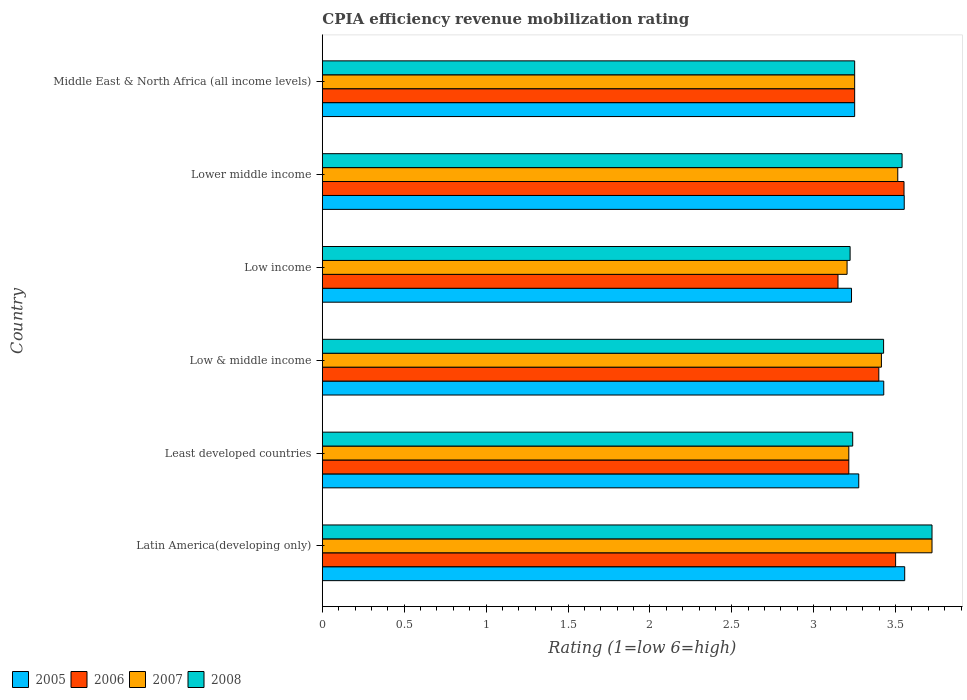How many different coloured bars are there?
Provide a short and direct response. 4. Are the number of bars per tick equal to the number of legend labels?
Provide a succinct answer. Yes. Are the number of bars on each tick of the Y-axis equal?
Your answer should be very brief. Yes. How many bars are there on the 1st tick from the top?
Provide a succinct answer. 4. How many bars are there on the 2nd tick from the bottom?
Provide a short and direct response. 4. In how many cases, is the number of bars for a given country not equal to the number of legend labels?
Offer a very short reply. 0. What is the CPIA rating in 2007 in Lower middle income?
Your response must be concise. 3.51. Across all countries, what is the maximum CPIA rating in 2007?
Give a very brief answer. 3.72. Across all countries, what is the minimum CPIA rating in 2006?
Make the answer very short. 3.15. In which country was the CPIA rating in 2007 maximum?
Give a very brief answer. Latin America(developing only). In which country was the CPIA rating in 2008 minimum?
Provide a succinct answer. Low income. What is the total CPIA rating in 2008 in the graph?
Keep it short and to the point. 20.4. What is the difference between the CPIA rating in 2007 in Least developed countries and that in Lower middle income?
Provide a short and direct response. -0.3. What is the difference between the CPIA rating in 2005 in Latin America(developing only) and the CPIA rating in 2007 in Lower middle income?
Your response must be concise. 0.04. What is the average CPIA rating in 2008 per country?
Your answer should be compact. 3.4. What is the difference between the CPIA rating in 2008 and CPIA rating in 2006 in Low income?
Provide a short and direct response. 0.07. What is the ratio of the CPIA rating in 2005 in Low income to that in Lower middle income?
Your response must be concise. 0.91. What is the difference between the highest and the second highest CPIA rating in 2005?
Offer a terse response. 0. What is the difference between the highest and the lowest CPIA rating in 2006?
Ensure brevity in your answer.  0.4. Is it the case that in every country, the sum of the CPIA rating in 2006 and CPIA rating in 2007 is greater than the sum of CPIA rating in 2008 and CPIA rating in 2005?
Give a very brief answer. No. What does the 1st bar from the top in Lower middle income represents?
Provide a short and direct response. 2008. Are all the bars in the graph horizontal?
Your answer should be compact. Yes. How many countries are there in the graph?
Offer a very short reply. 6. Does the graph contain any zero values?
Provide a short and direct response. No. Where does the legend appear in the graph?
Keep it short and to the point. Bottom left. How are the legend labels stacked?
Give a very brief answer. Horizontal. What is the title of the graph?
Give a very brief answer. CPIA efficiency revenue mobilization rating. Does "2015" appear as one of the legend labels in the graph?
Keep it short and to the point. No. What is the label or title of the X-axis?
Provide a short and direct response. Rating (1=low 6=high). What is the Rating (1=low 6=high) in 2005 in Latin America(developing only)?
Offer a terse response. 3.56. What is the Rating (1=low 6=high) of 2007 in Latin America(developing only)?
Make the answer very short. 3.72. What is the Rating (1=low 6=high) of 2008 in Latin America(developing only)?
Provide a short and direct response. 3.72. What is the Rating (1=low 6=high) in 2005 in Least developed countries?
Your answer should be very brief. 3.27. What is the Rating (1=low 6=high) of 2006 in Least developed countries?
Offer a terse response. 3.21. What is the Rating (1=low 6=high) of 2007 in Least developed countries?
Offer a very short reply. 3.21. What is the Rating (1=low 6=high) in 2008 in Least developed countries?
Provide a short and direct response. 3.24. What is the Rating (1=low 6=high) in 2005 in Low & middle income?
Provide a succinct answer. 3.43. What is the Rating (1=low 6=high) in 2006 in Low & middle income?
Keep it short and to the point. 3.4. What is the Rating (1=low 6=high) in 2007 in Low & middle income?
Provide a short and direct response. 3.41. What is the Rating (1=low 6=high) in 2008 in Low & middle income?
Your answer should be compact. 3.43. What is the Rating (1=low 6=high) in 2005 in Low income?
Provide a short and direct response. 3.23. What is the Rating (1=low 6=high) of 2006 in Low income?
Make the answer very short. 3.15. What is the Rating (1=low 6=high) of 2007 in Low income?
Keep it short and to the point. 3.2. What is the Rating (1=low 6=high) in 2008 in Low income?
Offer a terse response. 3.22. What is the Rating (1=low 6=high) in 2005 in Lower middle income?
Offer a terse response. 3.55. What is the Rating (1=low 6=high) of 2006 in Lower middle income?
Make the answer very short. 3.55. What is the Rating (1=low 6=high) of 2007 in Lower middle income?
Offer a very short reply. 3.51. What is the Rating (1=low 6=high) in 2008 in Lower middle income?
Offer a very short reply. 3.54. What is the Rating (1=low 6=high) of 2005 in Middle East & North Africa (all income levels)?
Give a very brief answer. 3.25. What is the Rating (1=low 6=high) of 2006 in Middle East & North Africa (all income levels)?
Offer a very short reply. 3.25. What is the Rating (1=low 6=high) of 2007 in Middle East & North Africa (all income levels)?
Keep it short and to the point. 3.25. Across all countries, what is the maximum Rating (1=low 6=high) of 2005?
Your answer should be compact. 3.56. Across all countries, what is the maximum Rating (1=low 6=high) of 2006?
Ensure brevity in your answer.  3.55. Across all countries, what is the maximum Rating (1=low 6=high) of 2007?
Provide a short and direct response. 3.72. Across all countries, what is the maximum Rating (1=low 6=high) in 2008?
Offer a terse response. 3.72. Across all countries, what is the minimum Rating (1=low 6=high) of 2005?
Offer a terse response. 3.23. Across all countries, what is the minimum Rating (1=low 6=high) in 2006?
Offer a terse response. 3.15. Across all countries, what is the minimum Rating (1=low 6=high) of 2007?
Your answer should be very brief. 3.2. Across all countries, what is the minimum Rating (1=low 6=high) of 2008?
Your answer should be very brief. 3.22. What is the total Rating (1=low 6=high) of 2005 in the graph?
Give a very brief answer. 20.29. What is the total Rating (1=low 6=high) in 2006 in the graph?
Offer a terse response. 20.06. What is the total Rating (1=low 6=high) in 2007 in the graph?
Your answer should be very brief. 20.32. What is the total Rating (1=low 6=high) of 2008 in the graph?
Your response must be concise. 20.4. What is the difference between the Rating (1=low 6=high) in 2005 in Latin America(developing only) and that in Least developed countries?
Ensure brevity in your answer.  0.28. What is the difference between the Rating (1=low 6=high) of 2006 in Latin America(developing only) and that in Least developed countries?
Offer a terse response. 0.29. What is the difference between the Rating (1=low 6=high) in 2007 in Latin America(developing only) and that in Least developed countries?
Your answer should be compact. 0.51. What is the difference between the Rating (1=low 6=high) in 2008 in Latin America(developing only) and that in Least developed countries?
Provide a short and direct response. 0.48. What is the difference between the Rating (1=low 6=high) in 2005 in Latin America(developing only) and that in Low & middle income?
Offer a terse response. 0.13. What is the difference between the Rating (1=low 6=high) of 2006 in Latin America(developing only) and that in Low & middle income?
Your response must be concise. 0.1. What is the difference between the Rating (1=low 6=high) of 2007 in Latin America(developing only) and that in Low & middle income?
Ensure brevity in your answer.  0.31. What is the difference between the Rating (1=low 6=high) in 2008 in Latin America(developing only) and that in Low & middle income?
Give a very brief answer. 0.3. What is the difference between the Rating (1=low 6=high) of 2005 in Latin America(developing only) and that in Low income?
Provide a short and direct response. 0.32. What is the difference between the Rating (1=low 6=high) of 2006 in Latin America(developing only) and that in Low income?
Provide a short and direct response. 0.35. What is the difference between the Rating (1=low 6=high) of 2007 in Latin America(developing only) and that in Low income?
Give a very brief answer. 0.52. What is the difference between the Rating (1=low 6=high) in 2005 in Latin America(developing only) and that in Lower middle income?
Give a very brief answer. 0. What is the difference between the Rating (1=low 6=high) of 2006 in Latin America(developing only) and that in Lower middle income?
Your response must be concise. -0.05. What is the difference between the Rating (1=low 6=high) in 2007 in Latin America(developing only) and that in Lower middle income?
Offer a very short reply. 0.21. What is the difference between the Rating (1=low 6=high) of 2008 in Latin America(developing only) and that in Lower middle income?
Provide a short and direct response. 0.18. What is the difference between the Rating (1=low 6=high) in 2005 in Latin America(developing only) and that in Middle East & North Africa (all income levels)?
Your answer should be compact. 0.31. What is the difference between the Rating (1=low 6=high) in 2007 in Latin America(developing only) and that in Middle East & North Africa (all income levels)?
Make the answer very short. 0.47. What is the difference between the Rating (1=low 6=high) of 2008 in Latin America(developing only) and that in Middle East & North Africa (all income levels)?
Give a very brief answer. 0.47. What is the difference between the Rating (1=low 6=high) in 2005 in Least developed countries and that in Low & middle income?
Offer a terse response. -0.15. What is the difference between the Rating (1=low 6=high) of 2006 in Least developed countries and that in Low & middle income?
Your answer should be compact. -0.18. What is the difference between the Rating (1=low 6=high) of 2007 in Least developed countries and that in Low & middle income?
Offer a terse response. -0.2. What is the difference between the Rating (1=low 6=high) of 2008 in Least developed countries and that in Low & middle income?
Provide a succinct answer. -0.19. What is the difference between the Rating (1=low 6=high) in 2005 in Least developed countries and that in Low income?
Ensure brevity in your answer.  0.04. What is the difference between the Rating (1=low 6=high) of 2006 in Least developed countries and that in Low income?
Ensure brevity in your answer.  0.07. What is the difference between the Rating (1=low 6=high) of 2007 in Least developed countries and that in Low income?
Ensure brevity in your answer.  0.01. What is the difference between the Rating (1=low 6=high) of 2008 in Least developed countries and that in Low income?
Give a very brief answer. 0.02. What is the difference between the Rating (1=low 6=high) in 2005 in Least developed countries and that in Lower middle income?
Provide a succinct answer. -0.28. What is the difference between the Rating (1=low 6=high) of 2006 in Least developed countries and that in Lower middle income?
Keep it short and to the point. -0.34. What is the difference between the Rating (1=low 6=high) of 2007 in Least developed countries and that in Lower middle income?
Your answer should be very brief. -0.3. What is the difference between the Rating (1=low 6=high) of 2008 in Least developed countries and that in Lower middle income?
Keep it short and to the point. -0.3. What is the difference between the Rating (1=low 6=high) of 2005 in Least developed countries and that in Middle East & North Africa (all income levels)?
Offer a very short reply. 0.03. What is the difference between the Rating (1=low 6=high) in 2006 in Least developed countries and that in Middle East & North Africa (all income levels)?
Offer a terse response. -0.04. What is the difference between the Rating (1=low 6=high) in 2007 in Least developed countries and that in Middle East & North Africa (all income levels)?
Offer a very short reply. -0.04. What is the difference between the Rating (1=low 6=high) of 2008 in Least developed countries and that in Middle East & North Africa (all income levels)?
Offer a terse response. -0.01. What is the difference between the Rating (1=low 6=high) of 2005 in Low & middle income and that in Low income?
Your response must be concise. 0.2. What is the difference between the Rating (1=low 6=high) in 2006 in Low & middle income and that in Low income?
Your answer should be compact. 0.25. What is the difference between the Rating (1=low 6=high) in 2007 in Low & middle income and that in Low income?
Make the answer very short. 0.21. What is the difference between the Rating (1=low 6=high) of 2008 in Low & middle income and that in Low income?
Your answer should be very brief. 0.2. What is the difference between the Rating (1=low 6=high) in 2005 in Low & middle income and that in Lower middle income?
Offer a terse response. -0.12. What is the difference between the Rating (1=low 6=high) in 2006 in Low & middle income and that in Lower middle income?
Your answer should be compact. -0.15. What is the difference between the Rating (1=low 6=high) in 2007 in Low & middle income and that in Lower middle income?
Offer a very short reply. -0.1. What is the difference between the Rating (1=low 6=high) in 2008 in Low & middle income and that in Lower middle income?
Ensure brevity in your answer.  -0.11. What is the difference between the Rating (1=low 6=high) of 2005 in Low & middle income and that in Middle East & North Africa (all income levels)?
Ensure brevity in your answer.  0.18. What is the difference between the Rating (1=low 6=high) of 2006 in Low & middle income and that in Middle East & North Africa (all income levels)?
Your response must be concise. 0.15. What is the difference between the Rating (1=low 6=high) in 2007 in Low & middle income and that in Middle East & North Africa (all income levels)?
Offer a very short reply. 0.16. What is the difference between the Rating (1=low 6=high) in 2008 in Low & middle income and that in Middle East & North Africa (all income levels)?
Keep it short and to the point. 0.18. What is the difference between the Rating (1=low 6=high) of 2005 in Low income and that in Lower middle income?
Offer a terse response. -0.32. What is the difference between the Rating (1=low 6=high) in 2006 in Low income and that in Lower middle income?
Ensure brevity in your answer.  -0.4. What is the difference between the Rating (1=low 6=high) in 2007 in Low income and that in Lower middle income?
Offer a terse response. -0.31. What is the difference between the Rating (1=low 6=high) of 2008 in Low income and that in Lower middle income?
Provide a short and direct response. -0.32. What is the difference between the Rating (1=low 6=high) in 2005 in Low income and that in Middle East & North Africa (all income levels)?
Give a very brief answer. -0.02. What is the difference between the Rating (1=low 6=high) of 2006 in Low income and that in Middle East & North Africa (all income levels)?
Offer a very short reply. -0.1. What is the difference between the Rating (1=low 6=high) of 2007 in Low income and that in Middle East & North Africa (all income levels)?
Your answer should be very brief. -0.05. What is the difference between the Rating (1=low 6=high) of 2008 in Low income and that in Middle East & North Africa (all income levels)?
Your response must be concise. -0.03. What is the difference between the Rating (1=low 6=high) of 2005 in Lower middle income and that in Middle East & North Africa (all income levels)?
Your answer should be very brief. 0.3. What is the difference between the Rating (1=low 6=high) in 2006 in Lower middle income and that in Middle East & North Africa (all income levels)?
Give a very brief answer. 0.3. What is the difference between the Rating (1=low 6=high) of 2007 in Lower middle income and that in Middle East & North Africa (all income levels)?
Provide a short and direct response. 0.26. What is the difference between the Rating (1=low 6=high) of 2008 in Lower middle income and that in Middle East & North Africa (all income levels)?
Ensure brevity in your answer.  0.29. What is the difference between the Rating (1=low 6=high) of 2005 in Latin America(developing only) and the Rating (1=low 6=high) of 2006 in Least developed countries?
Offer a terse response. 0.34. What is the difference between the Rating (1=low 6=high) in 2005 in Latin America(developing only) and the Rating (1=low 6=high) in 2007 in Least developed countries?
Your answer should be very brief. 0.34. What is the difference between the Rating (1=low 6=high) of 2005 in Latin America(developing only) and the Rating (1=low 6=high) of 2008 in Least developed countries?
Your response must be concise. 0.32. What is the difference between the Rating (1=low 6=high) of 2006 in Latin America(developing only) and the Rating (1=low 6=high) of 2007 in Least developed countries?
Give a very brief answer. 0.29. What is the difference between the Rating (1=low 6=high) in 2006 in Latin America(developing only) and the Rating (1=low 6=high) in 2008 in Least developed countries?
Your answer should be compact. 0.26. What is the difference between the Rating (1=low 6=high) of 2007 in Latin America(developing only) and the Rating (1=low 6=high) of 2008 in Least developed countries?
Offer a terse response. 0.48. What is the difference between the Rating (1=low 6=high) in 2005 in Latin America(developing only) and the Rating (1=low 6=high) in 2006 in Low & middle income?
Provide a succinct answer. 0.16. What is the difference between the Rating (1=low 6=high) of 2005 in Latin America(developing only) and the Rating (1=low 6=high) of 2007 in Low & middle income?
Your response must be concise. 0.14. What is the difference between the Rating (1=low 6=high) in 2005 in Latin America(developing only) and the Rating (1=low 6=high) in 2008 in Low & middle income?
Offer a very short reply. 0.13. What is the difference between the Rating (1=low 6=high) in 2006 in Latin America(developing only) and the Rating (1=low 6=high) in 2007 in Low & middle income?
Ensure brevity in your answer.  0.09. What is the difference between the Rating (1=low 6=high) in 2006 in Latin America(developing only) and the Rating (1=low 6=high) in 2008 in Low & middle income?
Your answer should be very brief. 0.07. What is the difference between the Rating (1=low 6=high) in 2007 in Latin America(developing only) and the Rating (1=low 6=high) in 2008 in Low & middle income?
Offer a terse response. 0.3. What is the difference between the Rating (1=low 6=high) in 2005 in Latin America(developing only) and the Rating (1=low 6=high) in 2006 in Low income?
Your response must be concise. 0.41. What is the difference between the Rating (1=low 6=high) in 2005 in Latin America(developing only) and the Rating (1=low 6=high) in 2007 in Low income?
Provide a succinct answer. 0.35. What is the difference between the Rating (1=low 6=high) of 2006 in Latin America(developing only) and the Rating (1=low 6=high) of 2007 in Low income?
Keep it short and to the point. 0.3. What is the difference between the Rating (1=low 6=high) in 2006 in Latin America(developing only) and the Rating (1=low 6=high) in 2008 in Low income?
Your response must be concise. 0.28. What is the difference between the Rating (1=low 6=high) in 2005 in Latin America(developing only) and the Rating (1=low 6=high) in 2006 in Lower middle income?
Your answer should be very brief. 0. What is the difference between the Rating (1=low 6=high) in 2005 in Latin America(developing only) and the Rating (1=low 6=high) in 2007 in Lower middle income?
Your response must be concise. 0.04. What is the difference between the Rating (1=low 6=high) of 2005 in Latin America(developing only) and the Rating (1=low 6=high) of 2008 in Lower middle income?
Provide a short and direct response. 0.02. What is the difference between the Rating (1=low 6=high) in 2006 in Latin America(developing only) and the Rating (1=low 6=high) in 2007 in Lower middle income?
Your answer should be very brief. -0.01. What is the difference between the Rating (1=low 6=high) of 2006 in Latin America(developing only) and the Rating (1=low 6=high) of 2008 in Lower middle income?
Keep it short and to the point. -0.04. What is the difference between the Rating (1=low 6=high) in 2007 in Latin America(developing only) and the Rating (1=low 6=high) in 2008 in Lower middle income?
Offer a very short reply. 0.18. What is the difference between the Rating (1=low 6=high) in 2005 in Latin America(developing only) and the Rating (1=low 6=high) in 2006 in Middle East & North Africa (all income levels)?
Provide a succinct answer. 0.31. What is the difference between the Rating (1=low 6=high) of 2005 in Latin America(developing only) and the Rating (1=low 6=high) of 2007 in Middle East & North Africa (all income levels)?
Your answer should be compact. 0.31. What is the difference between the Rating (1=low 6=high) in 2005 in Latin America(developing only) and the Rating (1=low 6=high) in 2008 in Middle East & North Africa (all income levels)?
Keep it short and to the point. 0.31. What is the difference between the Rating (1=low 6=high) in 2006 in Latin America(developing only) and the Rating (1=low 6=high) in 2007 in Middle East & North Africa (all income levels)?
Make the answer very short. 0.25. What is the difference between the Rating (1=low 6=high) of 2007 in Latin America(developing only) and the Rating (1=low 6=high) of 2008 in Middle East & North Africa (all income levels)?
Provide a short and direct response. 0.47. What is the difference between the Rating (1=low 6=high) in 2005 in Least developed countries and the Rating (1=low 6=high) in 2006 in Low & middle income?
Make the answer very short. -0.12. What is the difference between the Rating (1=low 6=high) of 2005 in Least developed countries and the Rating (1=low 6=high) of 2007 in Low & middle income?
Your answer should be very brief. -0.14. What is the difference between the Rating (1=low 6=high) in 2005 in Least developed countries and the Rating (1=low 6=high) in 2008 in Low & middle income?
Your answer should be very brief. -0.15. What is the difference between the Rating (1=low 6=high) in 2006 in Least developed countries and the Rating (1=low 6=high) in 2007 in Low & middle income?
Your response must be concise. -0.2. What is the difference between the Rating (1=low 6=high) of 2006 in Least developed countries and the Rating (1=low 6=high) of 2008 in Low & middle income?
Offer a very short reply. -0.21. What is the difference between the Rating (1=low 6=high) in 2007 in Least developed countries and the Rating (1=low 6=high) in 2008 in Low & middle income?
Ensure brevity in your answer.  -0.21. What is the difference between the Rating (1=low 6=high) in 2005 in Least developed countries and the Rating (1=low 6=high) in 2006 in Low income?
Keep it short and to the point. 0.13. What is the difference between the Rating (1=low 6=high) in 2005 in Least developed countries and the Rating (1=low 6=high) in 2007 in Low income?
Keep it short and to the point. 0.07. What is the difference between the Rating (1=low 6=high) of 2005 in Least developed countries and the Rating (1=low 6=high) of 2008 in Low income?
Give a very brief answer. 0.05. What is the difference between the Rating (1=low 6=high) of 2006 in Least developed countries and the Rating (1=low 6=high) of 2007 in Low income?
Offer a terse response. 0.01. What is the difference between the Rating (1=low 6=high) in 2006 in Least developed countries and the Rating (1=low 6=high) in 2008 in Low income?
Ensure brevity in your answer.  -0.01. What is the difference between the Rating (1=low 6=high) in 2007 in Least developed countries and the Rating (1=low 6=high) in 2008 in Low income?
Provide a short and direct response. -0.01. What is the difference between the Rating (1=low 6=high) of 2005 in Least developed countries and the Rating (1=low 6=high) of 2006 in Lower middle income?
Ensure brevity in your answer.  -0.28. What is the difference between the Rating (1=low 6=high) of 2005 in Least developed countries and the Rating (1=low 6=high) of 2007 in Lower middle income?
Your response must be concise. -0.24. What is the difference between the Rating (1=low 6=high) in 2005 in Least developed countries and the Rating (1=low 6=high) in 2008 in Lower middle income?
Your response must be concise. -0.26. What is the difference between the Rating (1=low 6=high) in 2006 in Least developed countries and the Rating (1=low 6=high) in 2007 in Lower middle income?
Keep it short and to the point. -0.3. What is the difference between the Rating (1=low 6=high) in 2006 in Least developed countries and the Rating (1=low 6=high) in 2008 in Lower middle income?
Give a very brief answer. -0.33. What is the difference between the Rating (1=low 6=high) in 2007 in Least developed countries and the Rating (1=low 6=high) in 2008 in Lower middle income?
Keep it short and to the point. -0.33. What is the difference between the Rating (1=low 6=high) of 2005 in Least developed countries and the Rating (1=low 6=high) of 2006 in Middle East & North Africa (all income levels)?
Your response must be concise. 0.03. What is the difference between the Rating (1=low 6=high) of 2005 in Least developed countries and the Rating (1=low 6=high) of 2007 in Middle East & North Africa (all income levels)?
Your answer should be very brief. 0.03. What is the difference between the Rating (1=low 6=high) of 2005 in Least developed countries and the Rating (1=low 6=high) of 2008 in Middle East & North Africa (all income levels)?
Your response must be concise. 0.03. What is the difference between the Rating (1=low 6=high) of 2006 in Least developed countries and the Rating (1=low 6=high) of 2007 in Middle East & North Africa (all income levels)?
Ensure brevity in your answer.  -0.04. What is the difference between the Rating (1=low 6=high) in 2006 in Least developed countries and the Rating (1=low 6=high) in 2008 in Middle East & North Africa (all income levels)?
Your response must be concise. -0.04. What is the difference between the Rating (1=low 6=high) of 2007 in Least developed countries and the Rating (1=low 6=high) of 2008 in Middle East & North Africa (all income levels)?
Provide a succinct answer. -0.04. What is the difference between the Rating (1=low 6=high) in 2005 in Low & middle income and the Rating (1=low 6=high) in 2006 in Low income?
Ensure brevity in your answer.  0.28. What is the difference between the Rating (1=low 6=high) of 2005 in Low & middle income and the Rating (1=low 6=high) of 2007 in Low income?
Provide a succinct answer. 0.22. What is the difference between the Rating (1=low 6=high) of 2005 in Low & middle income and the Rating (1=low 6=high) of 2008 in Low income?
Offer a terse response. 0.21. What is the difference between the Rating (1=low 6=high) of 2006 in Low & middle income and the Rating (1=low 6=high) of 2007 in Low income?
Your answer should be very brief. 0.19. What is the difference between the Rating (1=low 6=high) of 2006 in Low & middle income and the Rating (1=low 6=high) of 2008 in Low income?
Offer a very short reply. 0.18. What is the difference between the Rating (1=low 6=high) of 2007 in Low & middle income and the Rating (1=low 6=high) of 2008 in Low income?
Make the answer very short. 0.19. What is the difference between the Rating (1=low 6=high) in 2005 in Low & middle income and the Rating (1=low 6=high) in 2006 in Lower middle income?
Your answer should be compact. -0.12. What is the difference between the Rating (1=low 6=high) of 2005 in Low & middle income and the Rating (1=low 6=high) of 2007 in Lower middle income?
Give a very brief answer. -0.09. What is the difference between the Rating (1=low 6=high) of 2005 in Low & middle income and the Rating (1=low 6=high) of 2008 in Lower middle income?
Keep it short and to the point. -0.11. What is the difference between the Rating (1=low 6=high) in 2006 in Low & middle income and the Rating (1=low 6=high) in 2007 in Lower middle income?
Your answer should be very brief. -0.12. What is the difference between the Rating (1=low 6=high) in 2006 in Low & middle income and the Rating (1=low 6=high) in 2008 in Lower middle income?
Offer a very short reply. -0.14. What is the difference between the Rating (1=low 6=high) in 2007 in Low & middle income and the Rating (1=low 6=high) in 2008 in Lower middle income?
Offer a very short reply. -0.13. What is the difference between the Rating (1=low 6=high) of 2005 in Low & middle income and the Rating (1=low 6=high) of 2006 in Middle East & North Africa (all income levels)?
Your answer should be compact. 0.18. What is the difference between the Rating (1=low 6=high) of 2005 in Low & middle income and the Rating (1=low 6=high) of 2007 in Middle East & North Africa (all income levels)?
Your answer should be very brief. 0.18. What is the difference between the Rating (1=low 6=high) in 2005 in Low & middle income and the Rating (1=low 6=high) in 2008 in Middle East & North Africa (all income levels)?
Your response must be concise. 0.18. What is the difference between the Rating (1=low 6=high) in 2006 in Low & middle income and the Rating (1=low 6=high) in 2007 in Middle East & North Africa (all income levels)?
Keep it short and to the point. 0.15. What is the difference between the Rating (1=low 6=high) of 2006 in Low & middle income and the Rating (1=low 6=high) of 2008 in Middle East & North Africa (all income levels)?
Make the answer very short. 0.15. What is the difference between the Rating (1=low 6=high) of 2007 in Low & middle income and the Rating (1=low 6=high) of 2008 in Middle East & North Africa (all income levels)?
Offer a very short reply. 0.16. What is the difference between the Rating (1=low 6=high) of 2005 in Low income and the Rating (1=low 6=high) of 2006 in Lower middle income?
Provide a succinct answer. -0.32. What is the difference between the Rating (1=low 6=high) of 2005 in Low income and the Rating (1=low 6=high) of 2007 in Lower middle income?
Ensure brevity in your answer.  -0.28. What is the difference between the Rating (1=low 6=high) of 2005 in Low income and the Rating (1=low 6=high) of 2008 in Lower middle income?
Your answer should be compact. -0.31. What is the difference between the Rating (1=low 6=high) in 2006 in Low income and the Rating (1=low 6=high) in 2007 in Lower middle income?
Your response must be concise. -0.36. What is the difference between the Rating (1=low 6=high) in 2006 in Low income and the Rating (1=low 6=high) in 2008 in Lower middle income?
Offer a terse response. -0.39. What is the difference between the Rating (1=low 6=high) of 2007 in Low income and the Rating (1=low 6=high) of 2008 in Lower middle income?
Provide a short and direct response. -0.34. What is the difference between the Rating (1=low 6=high) of 2005 in Low income and the Rating (1=low 6=high) of 2006 in Middle East & North Africa (all income levels)?
Offer a terse response. -0.02. What is the difference between the Rating (1=low 6=high) in 2005 in Low income and the Rating (1=low 6=high) in 2007 in Middle East & North Africa (all income levels)?
Make the answer very short. -0.02. What is the difference between the Rating (1=low 6=high) of 2005 in Low income and the Rating (1=low 6=high) of 2008 in Middle East & North Africa (all income levels)?
Make the answer very short. -0.02. What is the difference between the Rating (1=low 6=high) in 2006 in Low income and the Rating (1=low 6=high) in 2007 in Middle East & North Africa (all income levels)?
Your response must be concise. -0.1. What is the difference between the Rating (1=low 6=high) of 2006 in Low income and the Rating (1=low 6=high) of 2008 in Middle East & North Africa (all income levels)?
Make the answer very short. -0.1. What is the difference between the Rating (1=low 6=high) of 2007 in Low income and the Rating (1=low 6=high) of 2008 in Middle East & North Africa (all income levels)?
Give a very brief answer. -0.05. What is the difference between the Rating (1=low 6=high) in 2005 in Lower middle income and the Rating (1=low 6=high) in 2006 in Middle East & North Africa (all income levels)?
Give a very brief answer. 0.3. What is the difference between the Rating (1=low 6=high) in 2005 in Lower middle income and the Rating (1=low 6=high) in 2007 in Middle East & North Africa (all income levels)?
Keep it short and to the point. 0.3. What is the difference between the Rating (1=low 6=high) of 2005 in Lower middle income and the Rating (1=low 6=high) of 2008 in Middle East & North Africa (all income levels)?
Ensure brevity in your answer.  0.3. What is the difference between the Rating (1=low 6=high) in 2006 in Lower middle income and the Rating (1=low 6=high) in 2007 in Middle East & North Africa (all income levels)?
Your response must be concise. 0.3. What is the difference between the Rating (1=low 6=high) of 2006 in Lower middle income and the Rating (1=low 6=high) of 2008 in Middle East & North Africa (all income levels)?
Ensure brevity in your answer.  0.3. What is the difference between the Rating (1=low 6=high) in 2007 in Lower middle income and the Rating (1=low 6=high) in 2008 in Middle East & North Africa (all income levels)?
Keep it short and to the point. 0.26. What is the average Rating (1=low 6=high) of 2005 per country?
Offer a terse response. 3.38. What is the average Rating (1=low 6=high) of 2006 per country?
Your response must be concise. 3.34. What is the average Rating (1=low 6=high) in 2007 per country?
Offer a very short reply. 3.39. What is the average Rating (1=low 6=high) of 2008 per country?
Ensure brevity in your answer.  3.4. What is the difference between the Rating (1=low 6=high) in 2005 and Rating (1=low 6=high) in 2006 in Latin America(developing only)?
Make the answer very short. 0.06. What is the difference between the Rating (1=low 6=high) of 2005 and Rating (1=low 6=high) of 2008 in Latin America(developing only)?
Keep it short and to the point. -0.17. What is the difference between the Rating (1=low 6=high) of 2006 and Rating (1=low 6=high) of 2007 in Latin America(developing only)?
Keep it short and to the point. -0.22. What is the difference between the Rating (1=low 6=high) in 2006 and Rating (1=low 6=high) in 2008 in Latin America(developing only)?
Offer a very short reply. -0.22. What is the difference between the Rating (1=low 6=high) of 2007 and Rating (1=low 6=high) of 2008 in Latin America(developing only)?
Offer a very short reply. 0. What is the difference between the Rating (1=low 6=high) in 2005 and Rating (1=low 6=high) in 2006 in Least developed countries?
Your answer should be very brief. 0.06. What is the difference between the Rating (1=low 6=high) in 2005 and Rating (1=low 6=high) in 2007 in Least developed countries?
Your answer should be compact. 0.06. What is the difference between the Rating (1=low 6=high) in 2005 and Rating (1=low 6=high) in 2008 in Least developed countries?
Your answer should be very brief. 0.04. What is the difference between the Rating (1=low 6=high) in 2006 and Rating (1=low 6=high) in 2007 in Least developed countries?
Give a very brief answer. 0. What is the difference between the Rating (1=low 6=high) of 2006 and Rating (1=low 6=high) of 2008 in Least developed countries?
Your response must be concise. -0.02. What is the difference between the Rating (1=low 6=high) of 2007 and Rating (1=low 6=high) of 2008 in Least developed countries?
Your answer should be compact. -0.02. What is the difference between the Rating (1=low 6=high) in 2005 and Rating (1=low 6=high) in 2006 in Low & middle income?
Your response must be concise. 0.03. What is the difference between the Rating (1=low 6=high) of 2005 and Rating (1=low 6=high) of 2007 in Low & middle income?
Keep it short and to the point. 0.01. What is the difference between the Rating (1=low 6=high) in 2006 and Rating (1=low 6=high) in 2007 in Low & middle income?
Make the answer very short. -0.02. What is the difference between the Rating (1=low 6=high) of 2006 and Rating (1=low 6=high) of 2008 in Low & middle income?
Your answer should be compact. -0.03. What is the difference between the Rating (1=low 6=high) of 2007 and Rating (1=low 6=high) of 2008 in Low & middle income?
Your answer should be very brief. -0.01. What is the difference between the Rating (1=low 6=high) of 2005 and Rating (1=low 6=high) of 2006 in Low income?
Give a very brief answer. 0.08. What is the difference between the Rating (1=low 6=high) in 2005 and Rating (1=low 6=high) in 2007 in Low income?
Provide a short and direct response. 0.03. What is the difference between the Rating (1=low 6=high) in 2005 and Rating (1=low 6=high) in 2008 in Low income?
Keep it short and to the point. 0.01. What is the difference between the Rating (1=low 6=high) in 2006 and Rating (1=low 6=high) in 2007 in Low income?
Offer a very short reply. -0.06. What is the difference between the Rating (1=low 6=high) of 2006 and Rating (1=low 6=high) of 2008 in Low income?
Keep it short and to the point. -0.07. What is the difference between the Rating (1=low 6=high) of 2007 and Rating (1=low 6=high) of 2008 in Low income?
Your answer should be compact. -0.02. What is the difference between the Rating (1=low 6=high) in 2005 and Rating (1=low 6=high) in 2006 in Lower middle income?
Your response must be concise. 0. What is the difference between the Rating (1=low 6=high) of 2005 and Rating (1=low 6=high) of 2007 in Lower middle income?
Offer a very short reply. 0.04. What is the difference between the Rating (1=low 6=high) of 2005 and Rating (1=low 6=high) of 2008 in Lower middle income?
Provide a short and direct response. 0.01. What is the difference between the Rating (1=low 6=high) of 2006 and Rating (1=low 6=high) of 2007 in Lower middle income?
Offer a very short reply. 0.04. What is the difference between the Rating (1=low 6=high) of 2006 and Rating (1=low 6=high) of 2008 in Lower middle income?
Your answer should be compact. 0.01. What is the difference between the Rating (1=low 6=high) of 2007 and Rating (1=low 6=high) of 2008 in Lower middle income?
Keep it short and to the point. -0.03. What is the difference between the Rating (1=low 6=high) of 2005 and Rating (1=low 6=high) of 2008 in Middle East & North Africa (all income levels)?
Keep it short and to the point. 0. What is the difference between the Rating (1=low 6=high) of 2006 and Rating (1=low 6=high) of 2007 in Middle East & North Africa (all income levels)?
Provide a succinct answer. 0. What is the ratio of the Rating (1=low 6=high) in 2005 in Latin America(developing only) to that in Least developed countries?
Give a very brief answer. 1.09. What is the ratio of the Rating (1=low 6=high) of 2006 in Latin America(developing only) to that in Least developed countries?
Your response must be concise. 1.09. What is the ratio of the Rating (1=low 6=high) in 2007 in Latin America(developing only) to that in Least developed countries?
Offer a terse response. 1.16. What is the ratio of the Rating (1=low 6=high) in 2008 in Latin America(developing only) to that in Least developed countries?
Your response must be concise. 1.15. What is the ratio of the Rating (1=low 6=high) in 2005 in Latin America(developing only) to that in Low & middle income?
Keep it short and to the point. 1.04. What is the ratio of the Rating (1=low 6=high) of 2006 in Latin America(developing only) to that in Low & middle income?
Make the answer very short. 1.03. What is the ratio of the Rating (1=low 6=high) of 2007 in Latin America(developing only) to that in Low & middle income?
Your answer should be very brief. 1.09. What is the ratio of the Rating (1=low 6=high) of 2008 in Latin America(developing only) to that in Low & middle income?
Make the answer very short. 1.09. What is the ratio of the Rating (1=low 6=high) of 2005 in Latin America(developing only) to that in Low income?
Your answer should be compact. 1.1. What is the ratio of the Rating (1=low 6=high) of 2006 in Latin America(developing only) to that in Low income?
Your answer should be compact. 1.11. What is the ratio of the Rating (1=low 6=high) of 2007 in Latin America(developing only) to that in Low income?
Offer a terse response. 1.16. What is the ratio of the Rating (1=low 6=high) of 2008 in Latin America(developing only) to that in Low income?
Keep it short and to the point. 1.16. What is the ratio of the Rating (1=low 6=high) of 2005 in Latin America(developing only) to that in Lower middle income?
Your answer should be compact. 1. What is the ratio of the Rating (1=low 6=high) of 2006 in Latin America(developing only) to that in Lower middle income?
Make the answer very short. 0.99. What is the ratio of the Rating (1=low 6=high) of 2007 in Latin America(developing only) to that in Lower middle income?
Your answer should be very brief. 1.06. What is the ratio of the Rating (1=low 6=high) of 2008 in Latin America(developing only) to that in Lower middle income?
Keep it short and to the point. 1.05. What is the ratio of the Rating (1=low 6=high) of 2005 in Latin America(developing only) to that in Middle East & North Africa (all income levels)?
Offer a very short reply. 1.09. What is the ratio of the Rating (1=low 6=high) of 2006 in Latin America(developing only) to that in Middle East & North Africa (all income levels)?
Your answer should be very brief. 1.08. What is the ratio of the Rating (1=low 6=high) of 2007 in Latin America(developing only) to that in Middle East & North Africa (all income levels)?
Your answer should be very brief. 1.15. What is the ratio of the Rating (1=low 6=high) of 2008 in Latin America(developing only) to that in Middle East & North Africa (all income levels)?
Offer a very short reply. 1.15. What is the ratio of the Rating (1=low 6=high) in 2005 in Least developed countries to that in Low & middle income?
Offer a very short reply. 0.96. What is the ratio of the Rating (1=low 6=high) in 2006 in Least developed countries to that in Low & middle income?
Offer a terse response. 0.95. What is the ratio of the Rating (1=low 6=high) of 2007 in Least developed countries to that in Low & middle income?
Make the answer very short. 0.94. What is the ratio of the Rating (1=low 6=high) in 2008 in Least developed countries to that in Low & middle income?
Provide a short and direct response. 0.94. What is the ratio of the Rating (1=low 6=high) in 2005 in Least developed countries to that in Low income?
Keep it short and to the point. 1.01. What is the ratio of the Rating (1=low 6=high) of 2008 in Least developed countries to that in Low income?
Offer a very short reply. 1. What is the ratio of the Rating (1=low 6=high) in 2005 in Least developed countries to that in Lower middle income?
Offer a terse response. 0.92. What is the ratio of the Rating (1=low 6=high) of 2006 in Least developed countries to that in Lower middle income?
Your response must be concise. 0.91. What is the ratio of the Rating (1=low 6=high) of 2007 in Least developed countries to that in Lower middle income?
Your answer should be compact. 0.91. What is the ratio of the Rating (1=low 6=high) in 2008 in Least developed countries to that in Lower middle income?
Offer a very short reply. 0.91. What is the ratio of the Rating (1=low 6=high) in 2005 in Least developed countries to that in Middle East & North Africa (all income levels)?
Ensure brevity in your answer.  1.01. What is the ratio of the Rating (1=low 6=high) of 2007 in Least developed countries to that in Middle East & North Africa (all income levels)?
Ensure brevity in your answer.  0.99. What is the ratio of the Rating (1=low 6=high) in 2005 in Low & middle income to that in Low income?
Your answer should be compact. 1.06. What is the ratio of the Rating (1=low 6=high) of 2006 in Low & middle income to that in Low income?
Provide a short and direct response. 1.08. What is the ratio of the Rating (1=low 6=high) of 2007 in Low & middle income to that in Low income?
Your response must be concise. 1.07. What is the ratio of the Rating (1=low 6=high) in 2008 in Low & middle income to that in Low income?
Your response must be concise. 1.06. What is the ratio of the Rating (1=low 6=high) of 2005 in Low & middle income to that in Lower middle income?
Your response must be concise. 0.96. What is the ratio of the Rating (1=low 6=high) of 2006 in Low & middle income to that in Lower middle income?
Your answer should be very brief. 0.96. What is the ratio of the Rating (1=low 6=high) of 2007 in Low & middle income to that in Lower middle income?
Keep it short and to the point. 0.97. What is the ratio of the Rating (1=low 6=high) of 2008 in Low & middle income to that in Lower middle income?
Offer a terse response. 0.97. What is the ratio of the Rating (1=low 6=high) in 2005 in Low & middle income to that in Middle East & North Africa (all income levels)?
Offer a terse response. 1.05. What is the ratio of the Rating (1=low 6=high) of 2006 in Low & middle income to that in Middle East & North Africa (all income levels)?
Ensure brevity in your answer.  1.05. What is the ratio of the Rating (1=low 6=high) of 2007 in Low & middle income to that in Middle East & North Africa (all income levels)?
Your response must be concise. 1.05. What is the ratio of the Rating (1=low 6=high) in 2008 in Low & middle income to that in Middle East & North Africa (all income levels)?
Keep it short and to the point. 1.05. What is the ratio of the Rating (1=low 6=high) in 2005 in Low income to that in Lower middle income?
Offer a very short reply. 0.91. What is the ratio of the Rating (1=low 6=high) in 2006 in Low income to that in Lower middle income?
Offer a very short reply. 0.89. What is the ratio of the Rating (1=low 6=high) of 2007 in Low income to that in Lower middle income?
Ensure brevity in your answer.  0.91. What is the ratio of the Rating (1=low 6=high) of 2008 in Low income to that in Lower middle income?
Provide a short and direct response. 0.91. What is the ratio of the Rating (1=low 6=high) of 2005 in Low income to that in Middle East & North Africa (all income levels)?
Provide a succinct answer. 0.99. What is the ratio of the Rating (1=low 6=high) in 2006 in Low income to that in Middle East & North Africa (all income levels)?
Your answer should be very brief. 0.97. What is the ratio of the Rating (1=low 6=high) in 2007 in Low income to that in Middle East & North Africa (all income levels)?
Your response must be concise. 0.99. What is the ratio of the Rating (1=low 6=high) in 2005 in Lower middle income to that in Middle East & North Africa (all income levels)?
Your response must be concise. 1.09. What is the ratio of the Rating (1=low 6=high) of 2006 in Lower middle income to that in Middle East & North Africa (all income levels)?
Your answer should be compact. 1.09. What is the ratio of the Rating (1=low 6=high) in 2007 in Lower middle income to that in Middle East & North Africa (all income levels)?
Offer a very short reply. 1.08. What is the ratio of the Rating (1=low 6=high) in 2008 in Lower middle income to that in Middle East & North Africa (all income levels)?
Give a very brief answer. 1.09. What is the difference between the highest and the second highest Rating (1=low 6=high) in 2005?
Ensure brevity in your answer.  0. What is the difference between the highest and the second highest Rating (1=low 6=high) of 2006?
Keep it short and to the point. 0.05. What is the difference between the highest and the second highest Rating (1=low 6=high) of 2007?
Provide a succinct answer. 0.21. What is the difference between the highest and the second highest Rating (1=low 6=high) of 2008?
Keep it short and to the point. 0.18. What is the difference between the highest and the lowest Rating (1=low 6=high) of 2005?
Keep it short and to the point. 0.32. What is the difference between the highest and the lowest Rating (1=low 6=high) of 2006?
Your answer should be very brief. 0.4. What is the difference between the highest and the lowest Rating (1=low 6=high) in 2007?
Ensure brevity in your answer.  0.52. 